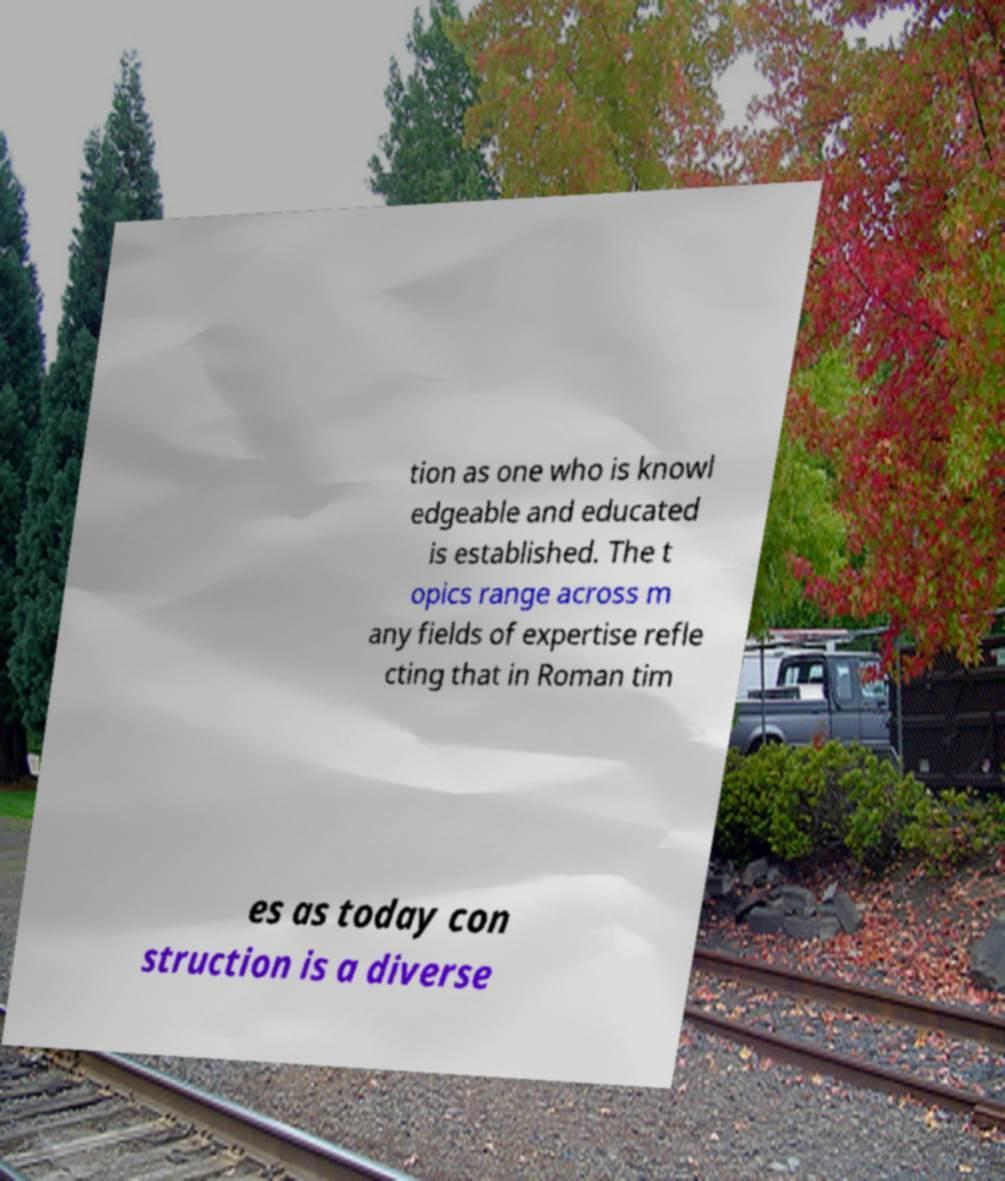Can you accurately transcribe the text from the provided image for me? tion as one who is knowl edgeable and educated is established. The t opics range across m any fields of expertise refle cting that in Roman tim es as today con struction is a diverse 